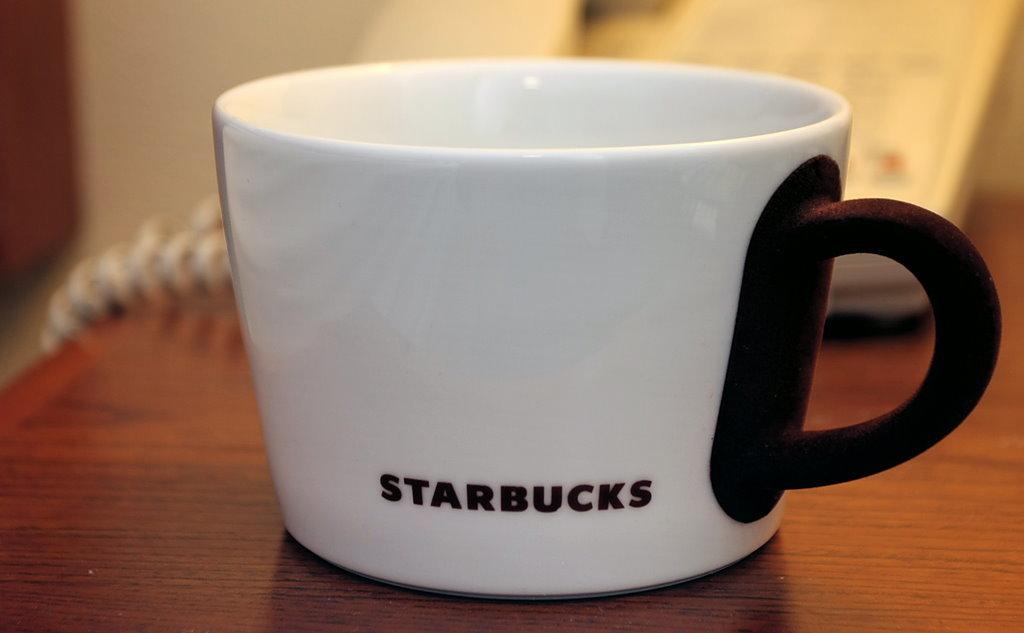What company name is on this mug?
Your response must be concise. Starbucks. 